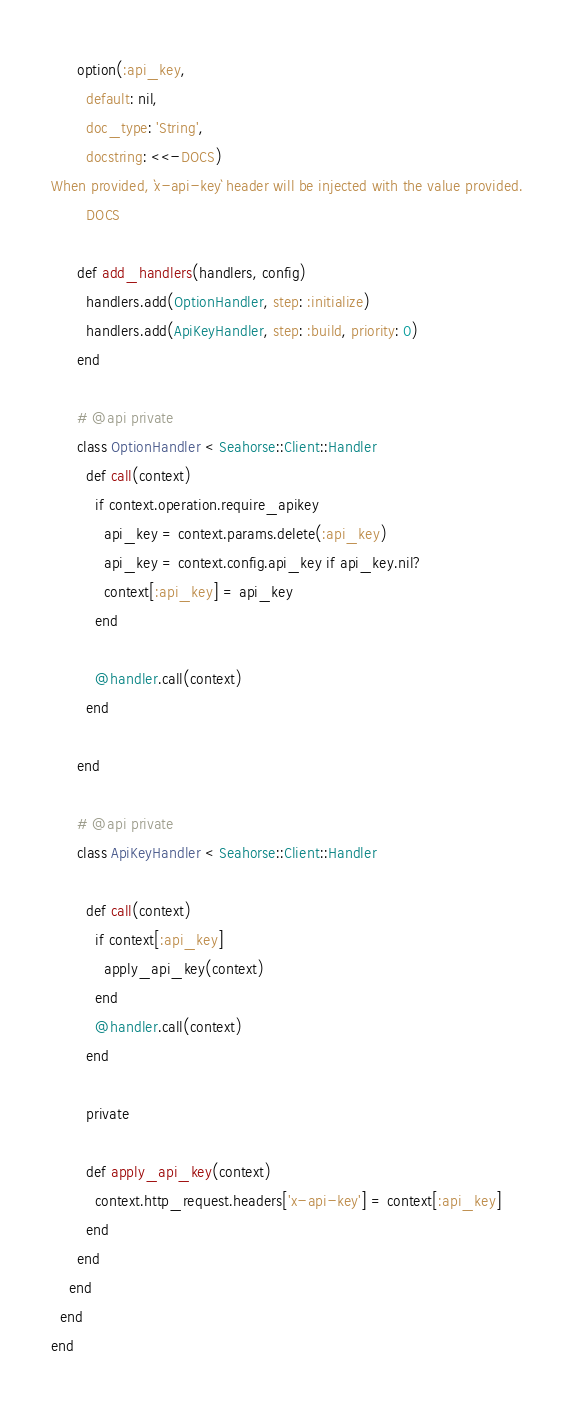Convert code to text. <code><loc_0><loc_0><loc_500><loc_500><_Ruby_>      option(:api_key,
        default: nil,
        doc_type: 'String',
        docstring: <<-DOCS)
When provided, `x-api-key` header will be injected with the value provided.
        DOCS

      def add_handlers(handlers, config)
        handlers.add(OptionHandler, step: :initialize)
        handlers.add(ApiKeyHandler, step: :build, priority: 0)
      end

      # @api private
      class OptionHandler < Seahorse::Client::Handler
        def call(context)
          if context.operation.require_apikey
            api_key = context.params.delete(:api_key)
            api_key = context.config.api_key if api_key.nil?
            context[:api_key] = api_key
          end

          @handler.call(context)
        end

      end

      # @api private
      class ApiKeyHandler < Seahorse::Client::Handler

        def call(context)
          if context[:api_key]
            apply_api_key(context)
          end
          @handler.call(context)
        end

        private

        def apply_api_key(context)
          context.http_request.headers['x-api-key'] = context[:api_key]
        end
      end
    end
  end
end
</code> 